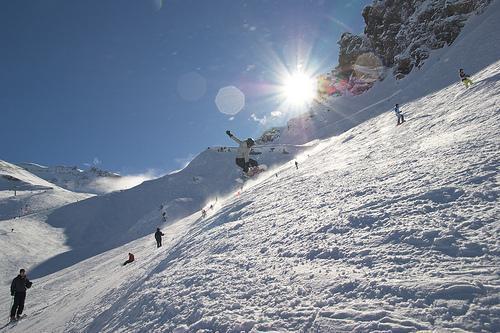How many people were captured in the air?
Give a very brief answer. 1. 